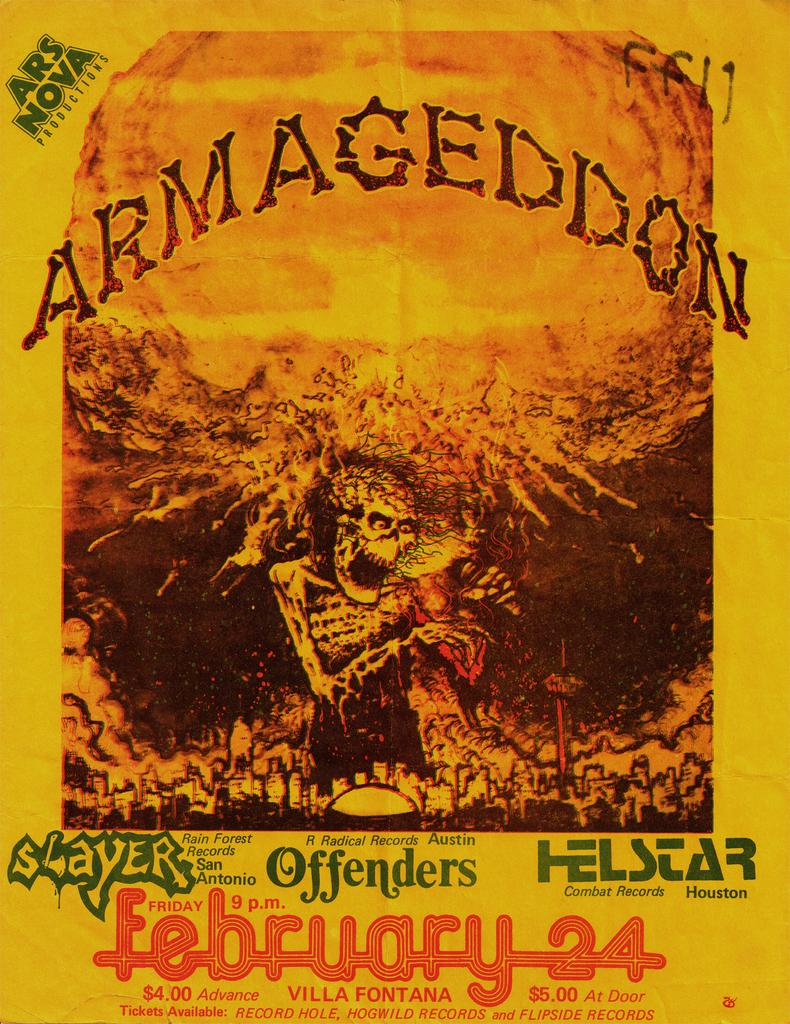<image>
Relay a brief, clear account of the picture shown. poster for armageddon concert on february 24 at 9pm featuring slayer, offenders, and helstar 